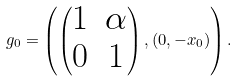<formula> <loc_0><loc_0><loc_500><loc_500>g _ { 0 } = \left ( \begin{pmatrix} 1 & \alpha \\ 0 & 1 \end{pmatrix} , ( 0 , - x _ { 0 } ) \right ) .</formula> 